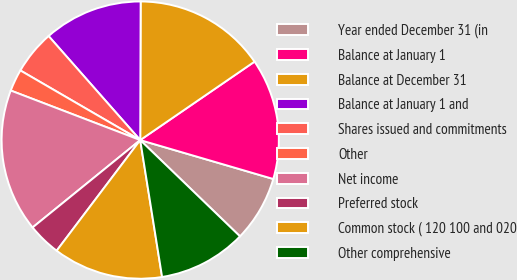<chart> <loc_0><loc_0><loc_500><loc_500><pie_chart><fcel>Year ended December 31 (in<fcel>Balance at January 1<fcel>Balance at December 31<fcel>Balance at January 1 and<fcel>Shares issued and commitments<fcel>Other<fcel>Net income<fcel>Preferred stock<fcel>Common stock ( 120 100 and 020<fcel>Other comprehensive<nl><fcel>7.69%<fcel>14.1%<fcel>15.38%<fcel>11.54%<fcel>5.13%<fcel>2.56%<fcel>16.67%<fcel>3.85%<fcel>12.82%<fcel>10.26%<nl></chart> 